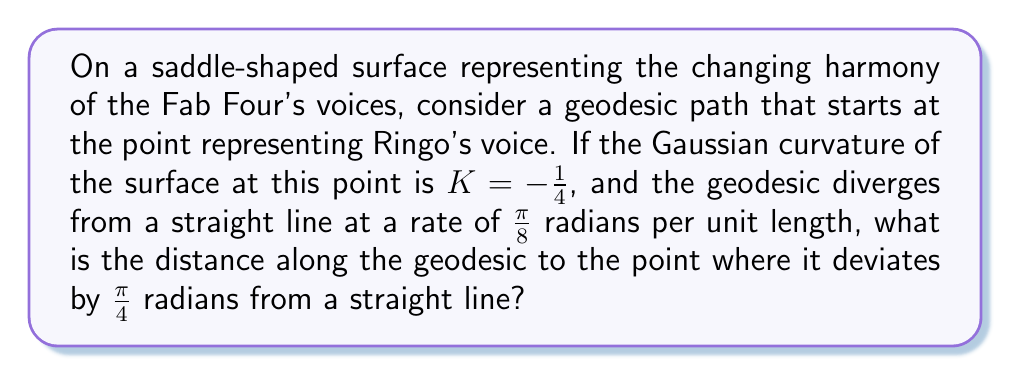Teach me how to tackle this problem. Let's approach this step-by-step:

1) In non-Euclidean geometry, geodesics on a surface with negative Gaussian curvature diverge from straight lines. The rate of divergence is related to the curvature of the surface.

2) The Gaussian curvature at Ringo's point is given as $K = -\frac{1}{4}$.

3) The geodesic divergence formula for a surface with constant negative curvature is:

   $$\theta = \frac{s}{\sqrt{-\frac{1}{K}}}$$

   where $\theta$ is the angle of divergence, $s$ is the distance along the geodesic, and $K$ is the Gaussian curvature.

4) We're given that the rate of divergence is $\frac{\pi}{8}$ radians per unit length. This means:

   $$\frac{\pi}{8} = \frac{1}{\sqrt{-\frac{1}{K}}}$$

5) Substituting $K = -\frac{1}{4}$:

   $$\frac{\pi}{8} = \frac{1}{\sqrt{4}} = \frac{1}{2}$$

   This confirms that our given rate of divergence is consistent with the curvature.

6) Now, we want to find the distance $s$ where the total divergence is $\frac{\pi}{4}$. Using the formula from step 3:

   $$\frac{\pi}{4} = \frac{s}{\sqrt{4}} = \frac{s}{2}$$

7) Solving for $s$:

   $$s = \frac{\pi}{4} \cdot 2 = \frac{\pi}{2}$$

Therefore, the distance along the geodesic to the point where it deviates by $\frac{\pi}{4}$ radians from a straight line is $\frac{\pi}{2}$ units.
Answer: $\frac{\pi}{2}$ units 